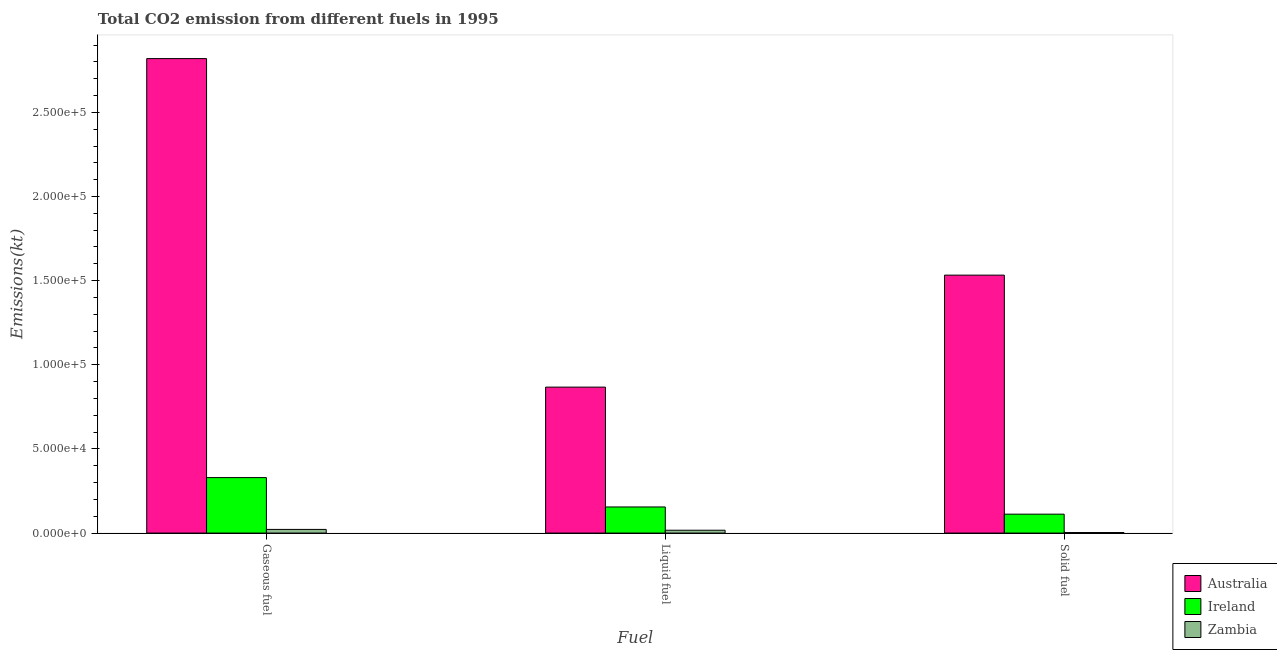How many groups of bars are there?
Provide a short and direct response. 3. Are the number of bars per tick equal to the number of legend labels?
Give a very brief answer. Yes. How many bars are there on the 1st tick from the left?
Make the answer very short. 3. What is the label of the 3rd group of bars from the left?
Offer a very short reply. Solid fuel. What is the amount of co2 emissions from solid fuel in Ireland?
Your response must be concise. 1.12e+04. Across all countries, what is the maximum amount of co2 emissions from gaseous fuel?
Offer a very short reply. 2.82e+05. Across all countries, what is the minimum amount of co2 emissions from solid fuel?
Ensure brevity in your answer.  330.03. In which country was the amount of co2 emissions from solid fuel minimum?
Keep it short and to the point. Zambia. What is the total amount of co2 emissions from gaseous fuel in the graph?
Provide a succinct answer. 3.17e+05. What is the difference between the amount of co2 emissions from gaseous fuel in Ireland and that in Australia?
Give a very brief answer. -2.49e+05. What is the difference between the amount of co2 emissions from gaseous fuel in Zambia and the amount of co2 emissions from solid fuel in Ireland?
Give a very brief answer. -9064.82. What is the average amount of co2 emissions from solid fuel per country?
Provide a short and direct response. 5.49e+04. What is the difference between the amount of co2 emissions from liquid fuel and amount of co2 emissions from gaseous fuel in Ireland?
Provide a short and direct response. -1.74e+04. In how many countries, is the amount of co2 emissions from liquid fuel greater than 170000 kt?
Ensure brevity in your answer.  0. What is the ratio of the amount of co2 emissions from liquid fuel in Australia to that in Zambia?
Give a very brief answer. 51.42. What is the difference between the highest and the second highest amount of co2 emissions from gaseous fuel?
Offer a very short reply. 2.49e+05. What is the difference between the highest and the lowest amount of co2 emissions from gaseous fuel?
Provide a short and direct response. 2.80e+05. Is the sum of the amount of co2 emissions from liquid fuel in Ireland and Zambia greater than the maximum amount of co2 emissions from gaseous fuel across all countries?
Offer a terse response. No. What does the 2nd bar from the left in Liquid fuel represents?
Keep it short and to the point. Ireland. What does the 2nd bar from the right in Gaseous fuel represents?
Your answer should be compact. Ireland. How many bars are there?
Offer a terse response. 9. Are all the bars in the graph horizontal?
Ensure brevity in your answer.  No. How many countries are there in the graph?
Your answer should be very brief. 3. What is the difference between two consecutive major ticks on the Y-axis?
Your answer should be very brief. 5.00e+04. Does the graph contain any zero values?
Keep it short and to the point. No. Does the graph contain grids?
Keep it short and to the point. No. How many legend labels are there?
Your answer should be compact. 3. How are the legend labels stacked?
Keep it short and to the point. Vertical. What is the title of the graph?
Keep it short and to the point. Total CO2 emission from different fuels in 1995. What is the label or title of the X-axis?
Provide a short and direct response. Fuel. What is the label or title of the Y-axis?
Offer a very short reply. Emissions(kt). What is the Emissions(kt) in Australia in Gaseous fuel?
Offer a very short reply. 2.82e+05. What is the Emissions(kt) in Ireland in Gaseous fuel?
Make the answer very short. 3.30e+04. What is the Emissions(kt) in Zambia in Gaseous fuel?
Your answer should be compact. 2170.86. What is the Emissions(kt) of Australia in Liquid fuel?
Ensure brevity in your answer.  8.67e+04. What is the Emissions(kt) of Ireland in Liquid fuel?
Offer a very short reply. 1.55e+04. What is the Emissions(kt) of Zambia in Liquid fuel?
Your response must be concise. 1686.82. What is the Emissions(kt) in Australia in Solid fuel?
Keep it short and to the point. 1.53e+05. What is the Emissions(kt) of Ireland in Solid fuel?
Keep it short and to the point. 1.12e+04. What is the Emissions(kt) of Zambia in Solid fuel?
Provide a succinct answer. 330.03. Across all Fuel, what is the maximum Emissions(kt) of Australia?
Your answer should be very brief. 2.82e+05. Across all Fuel, what is the maximum Emissions(kt) of Ireland?
Provide a succinct answer. 3.30e+04. Across all Fuel, what is the maximum Emissions(kt) of Zambia?
Provide a succinct answer. 2170.86. Across all Fuel, what is the minimum Emissions(kt) in Australia?
Keep it short and to the point. 8.67e+04. Across all Fuel, what is the minimum Emissions(kt) in Ireland?
Provide a succinct answer. 1.12e+04. Across all Fuel, what is the minimum Emissions(kt) of Zambia?
Offer a very short reply. 330.03. What is the total Emissions(kt) of Australia in the graph?
Offer a very short reply. 5.22e+05. What is the total Emissions(kt) in Ireland in the graph?
Your answer should be very brief. 5.97e+04. What is the total Emissions(kt) of Zambia in the graph?
Give a very brief answer. 4187.71. What is the difference between the Emissions(kt) in Australia in Gaseous fuel and that in Liquid fuel?
Keep it short and to the point. 1.95e+05. What is the difference between the Emissions(kt) of Ireland in Gaseous fuel and that in Liquid fuel?
Provide a succinct answer. 1.74e+04. What is the difference between the Emissions(kt) of Zambia in Gaseous fuel and that in Liquid fuel?
Provide a short and direct response. 484.04. What is the difference between the Emissions(kt) in Australia in Gaseous fuel and that in Solid fuel?
Provide a short and direct response. 1.29e+05. What is the difference between the Emissions(kt) in Ireland in Gaseous fuel and that in Solid fuel?
Make the answer very short. 2.17e+04. What is the difference between the Emissions(kt) of Zambia in Gaseous fuel and that in Solid fuel?
Offer a very short reply. 1840.83. What is the difference between the Emissions(kt) in Australia in Liquid fuel and that in Solid fuel?
Make the answer very short. -6.65e+04. What is the difference between the Emissions(kt) in Ireland in Liquid fuel and that in Solid fuel?
Provide a succinct answer. 4279.39. What is the difference between the Emissions(kt) in Zambia in Liquid fuel and that in Solid fuel?
Give a very brief answer. 1356.79. What is the difference between the Emissions(kt) of Australia in Gaseous fuel and the Emissions(kt) of Ireland in Liquid fuel?
Ensure brevity in your answer.  2.66e+05. What is the difference between the Emissions(kt) in Australia in Gaseous fuel and the Emissions(kt) in Zambia in Liquid fuel?
Provide a succinct answer. 2.80e+05. What is the difference between the Emissions(kt) in Ireland in Gaseous fuel and the Emissions(kt) in Zambia in Liquid fuel?
Offer a very short reply. 3.13e+04. What is the difference between the Emissions(kt) of Australia in Gaseous fuel and the Emissions(kt) of Ireland in Solid fuel?
Ensure brevity in your answer.  2.71e+05. What is the difference between the Emissions(kt) of Australia in Gaseous fuel and the Emissions(kt) of Zambia in Solid fuel?
Keep it short and to the point. 2.82e+05. What is the difference between the Emissions(kt) in Ireland in Gaseous fuel and the Emissions(kt) in Zambia in Solid fuel?
Your answer should be very brief. 3.26e+04. What is the difference between the Emissions(kt) of Australia in Liquid fuel and the Emissions(kt) of Ireland in Solid fuel?
Provide a succinct answer. 7.55e+04. What is the difference between the Emissions(kt) in Australia in Liquid fuel and the Emissions(kt) in Zambia in Solid fuel?
Provide a succinct answer. 8.64e+04. What is the difference between the Emissions(kt) in Ireland in Liquid fuel and the Emissions(kt) in Zambia in Solid fuel?
Your response must be concise. 1.52e+04. What is the average Emissions(kt) in Australia per Fuel?
Ensure brevity in your answer.  1.74e+05. What is the average Emissions(kt) in Ireland per Fuel?
Your answer should be compact. 1.99e+04. What is the average Emissions(kt) in Zambia per Fuel?
Your answer should be compact. 1395.9. What is the difference between the Emissions(kt) of Australia and Emissions(kt) of Ireland in Gaseous fuel?
Keep it short and to the point. 2.49e+05. What is the difference between the Emissions(kt) in Australia and Emissions(kt) in Zambia in Gaseous fuel?
Your answer should be compact. 2.80e+05. What is the difference between the Emissions(kt) in Ireland and Emissions(kt) in Zambia in Gaseous fuel?
Your response must be concise. 3.08e+04. What is the difference between the Emissions(kt) in Australia and Emissions(kt) in Ireland in Liquid fuel?
Make the answer very short. 7.12e+04. What is the difference between the Emissions(kt) of Australia and Emissions(kt) of Zambia in Liquid fuel?
Your response must be concise. 8.50e+04. What is the difference between the Emissions(kt) in Ireland and Emissions(kt) in Zambia in Liquid fuel?
Give a very brief answer. 1.38e+04. What is the difference between the Emissions(kt) of Australia and Emissions(kt) of Ireland in Solid fuel?
Provide a short and direct response. 1.42e+05. What is the difference between the Emissions(kt) in Australia and Emissions(kt) in Zambia in Solid fuel?
Your answer should be very brief. 1.53e+05. What is the difference between the Emissions(kt) in Ireland and Emissions(kt) in Zambia in Solid fuel?
Ensure brevity in your answer.  1.09e+04. What is the ratio of the Emissions(kt) in Australia in Gaseous fuel to that in Liquid fuel?
Ensure brevity in your answer.  3.25. What is the ratio of the Emissions(kt) in Ireland in Gaseous fuel to that in Liquid fuel?
Ensure brevity in your answer.  2.12. What is the ratio of the Emissions(kt) in Zambia in Gaseous fuel to that in Liquid fuel?
Provide a succinct answer. 1.29. What is the ratio of the Emissions(kt) in Australia in Gaseous fuel to that in Solid fuel?
Offer a very short reply. 1.84. What is the ratio of the Emissions(kt) of Ireland in Gaseous fuel to that in Solid fuel?
Offer a very short reply. 2.93. What is the ratio of the Emissions(kt) in Zambia in Gaseous fuel to that in Solid fuel?
Your answer should be compact. 6.58. What is the ratio of the Emissions(kt) in Australia in Liquid fuel to that in Solid fuel?
Offer a terse response. 0.57. What is the ratio of the Emissions(kt) in Ireland in Liquid fuel to that in Solid fuel?
Give a very brief answer. 1.38. What is the ratio of the Emissions(kt) in Zambia in Liquid fuel to that in Solid fuel?
Provide a short and direct response. 5.11. What is the difference between the highest and the second highest Emissions(kt) in Australia?
Offer a very short reply. 1.29e+05. What is the difference between the highest and the second highest Emissions(kt) in Ireland?
Offer a very short reply. 1.74e+04. What is the difference between the highest and the second highest Emissions(kt) in Zambia?
Provide a short and direct response. 484.04. What is the difference between the highest and the lowest Emissions(kt) of Australia?
Keep it short and to the point. 1.95e+05. What is the difference between the highest and the lowest Emissions(kt) of Ireland?
Provide a succinct answer. 2.17e+04. What is the difference between the highest and the lowest Emissions(kt) of Zambia?
Give a very brief answer. 1840.83. 